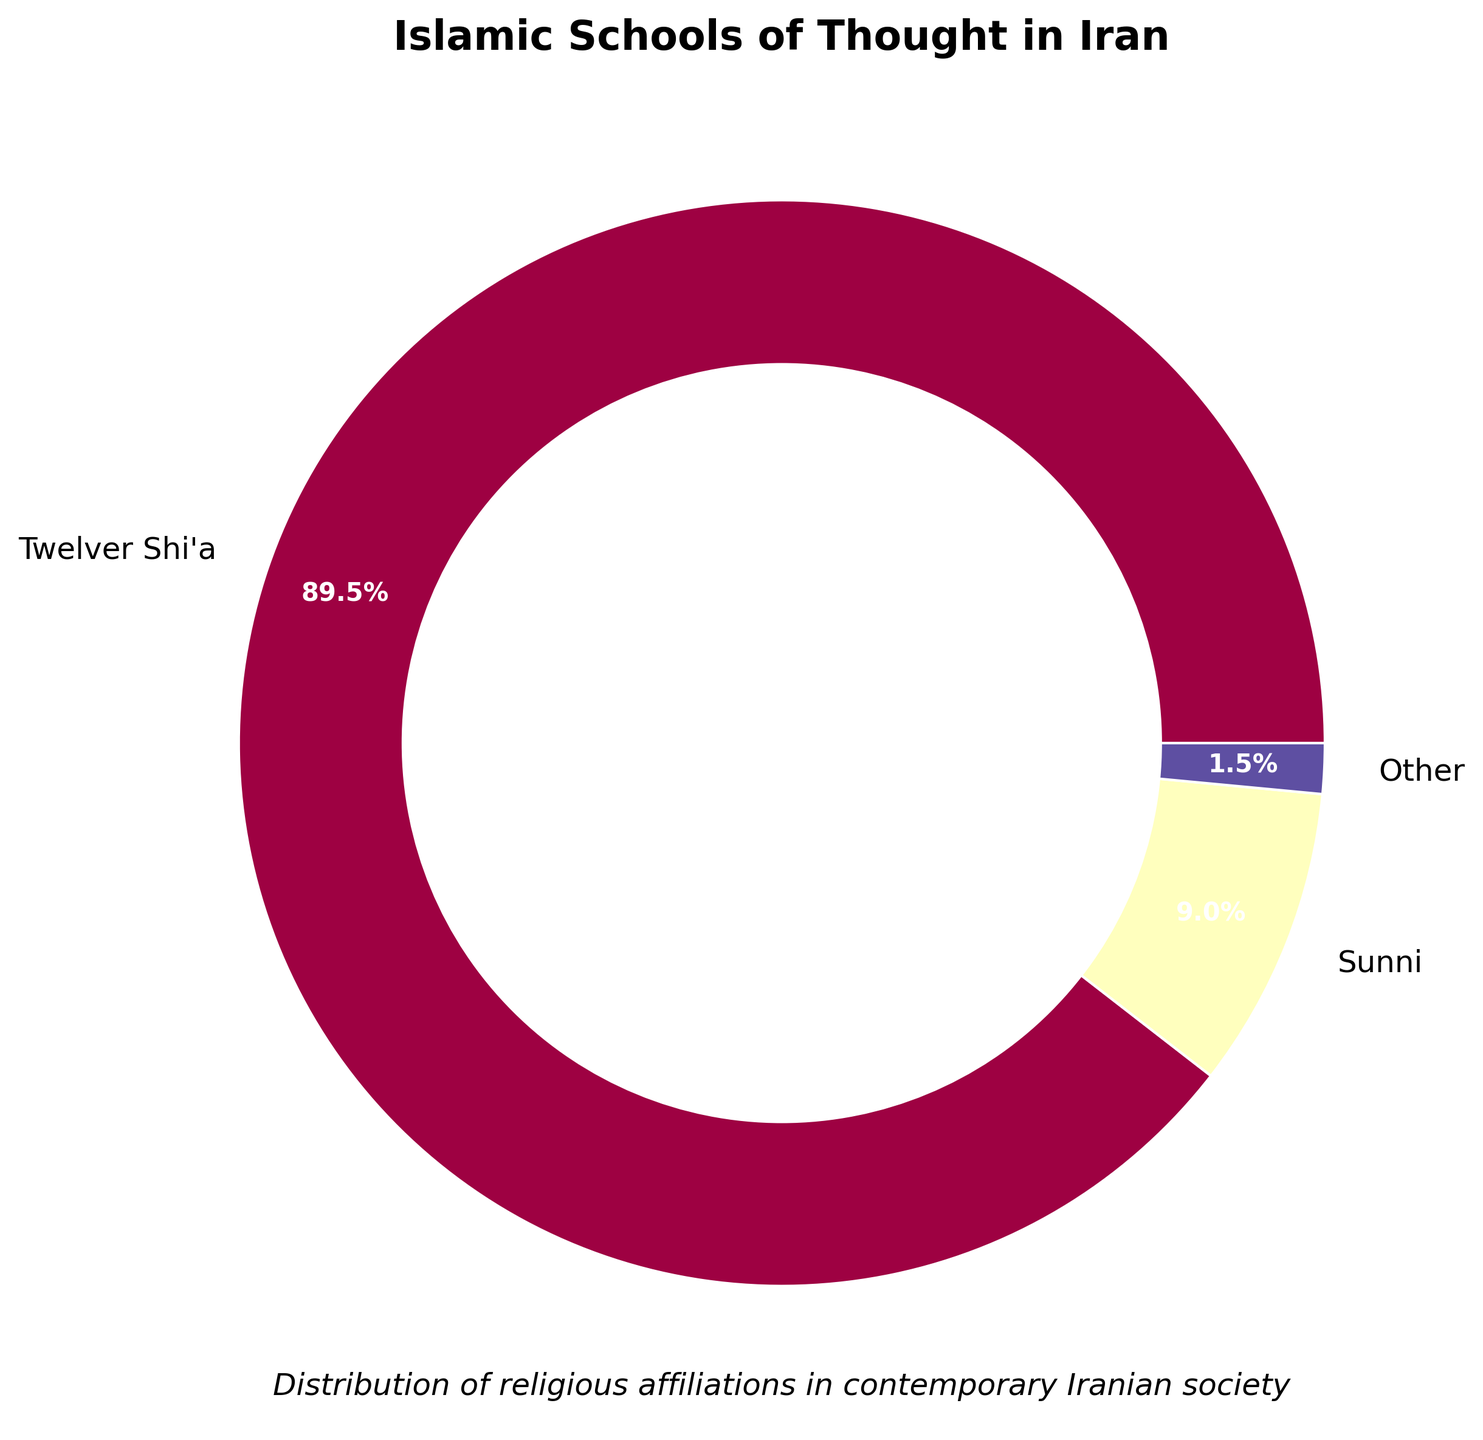Which Islamic school of thought has the highest percentage in Iran? The wedge with the largest percentage represents the Twelver Shi'a, as indicated by both its size and the label showing 89.5%.
Answer: Twelver Shi'a What is the combined percentage of Sunni and Sufi Muslims in Iran? The pie chart shows that Sunni Muslims constitute 9% and Sufi Muslims make up 0.7%. Adding these two percentages: 9% + 0.7% = 9.7%.
Answer: 9.7% Which school of thought has a smaller percentage: Ahl-e Haqq or Baha'i? By examining the chart, both Ahl-e Haqq and Baha'i are represented, but Ahl-e Haqq has a higher percentage at 0.2% compared to Baha'i's 0.1%.
Answer: Baha'i What color is used to represent the 'Other' category? By looking at the pie chart, the 'Other' category is represented by a distinct color which is a shade within the color spectrum used.
Answer: A specific shade (provide the exact color seen on the chart) How does the percentage of 'Other' compare with the percentage of the second-largest group? The 'Other' category is formed by summing the smaller percentages (Ismaili, Ahl-e Haqq, Zoroastrian, Baha'i, Christian). This sum is less than the percentage of the second-largest group, Sunni (9%).
Answer: Less than Sunni Which school of thought has the smallest representation and what is its percentage? The smallest wedges in the chart are examined to find that Zoroastrian, Baha'i, and Christian each have the smallest representation at 0.1%.
Answer: Zoroastrian, Baha'i, and Christian (each 0.1%) What is the total percentage represented by the 'Other' category? The 'Other' category combines the Ismaili (0.3%), Ahl-e Haqq (0.2%), Zoroastrian (0.1%), Baha'i (0.1%), and Christian (0.1%). Adding them: 0.3% + 0.2% + 0.1% + 0.1% + 0.1% = 0.8%.
Answer: 0.8% What proportion of the total does the Sunni population represent compared to the Twelver Shi'a population? The pie chart shows Sunni at 9% and Twelver Shi'a at 89.5%. The proportion is calculated by dividing the percentage of Sunni by the percentage of Twelver Shi'a: 9% / 89.5% ≈ 0.1006, approximately 10%.
Answer: Approximately 10% How many distinct group labels are visible on the pie chart? Although the data lists eight groups, the chart may merge smaller groups into an 'Other' category, making the number of distinct labels visible seven.
Answer: Seven 